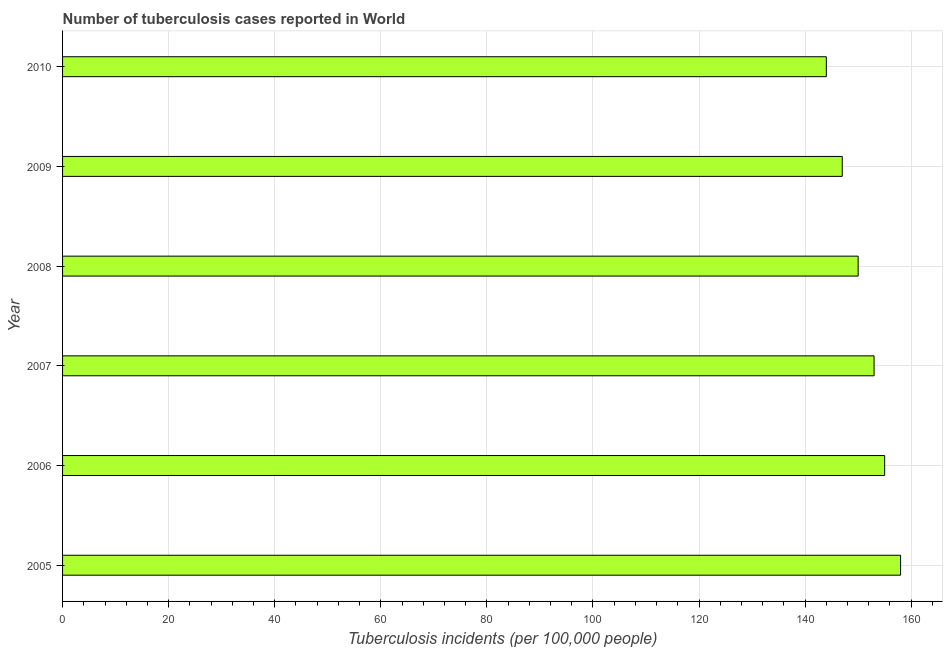Does the graph contain any zero values?
Keep it short and to the point. No. Does the graph contain grids?
Give a very brief answer. Yes. What is the title of the graph?
Ensure brevity in your answer.  Number of tuberculosis cases reported in World. What is the label or title of the X-axis?
Provide a succinct answer. Tuberculosis incidents (per 100,0 people). What is the label or title of the Y-axis?
Provide a short and direct response. Year. What is the number of tuberculosis incidents in 2008?
Make the answer very short. 150. Across all years, what is the maximum number of tuberculosis incidents?
Your answer should be very brief. 158. Across all years, what is the minimum number of tuberculosis incidents?
Provide a short and direct response. 144. In which year was the number of tuberculosis incidents minimum?
Your response must be concise. 2010. What is the sum of the number of tuberculosis incidents?
Ensure brevity in your answer.  907. What is the average number of tuberculosis incidents per year?
Ensure brevity in your answer.  151. What is the median number of tuberculosis incidents?
Give a very brief answer. 151.5. In how many years, is the number of tuberculosis incidents greater than 36 ?
Your answer should be compact. 6. Do a majority of the years between 2010 and 2005 (inclusive) have number of tuberculosis incidents greater than 24 ?
Your answer should be compact. Yes. What is the ratio of the number of tuberculosis incidents in 2007 to that in 2010?
Keep it short and to the point. 1.06. Is the difference between the number of tuberculosis incidents in 2006 and 2008 greater than the difference between any two years?
Ensure brevity in your answer.  No. Is the sum of the number of tuberculosis incidents in 2006 and 2008 greater than the maximum number of tuberculosis incidents across all years?
Give a very brief answer. Yes. Are all the bars in the graph horizontal?
Your answer should be very brief. Yes. How many years are there in the graph?
Offer a terse response. 6. Are the values on the major ticks of X-axis written in scientific E-notation?
Offer a very short reply. No. What is the Tuberculosis incidents (per 100,000 people) of 2005?
Give a very brief answer. 158. What is the Tuberculosis incidents (per 100,000 people) of 2006?
Ensure brevity in your answer.  155. What is the Tuberculosis incidents (per 100,000 people) in 2007?
Provide a succinct answer. 153. What is the Tuberculosis incidents (per 100,000 people) in 2008?
Give a very brief answer. 150. What is the Tuberculosis incidents (per 100,000 people) in 2009?
Your response must be concise. 147. What is the Tuberculosis incidents (per 100,000 people) in 2010?
Ensure brevity in your answer.  144. What is the difference between the Tuberculosis incidents (per 100,000 people) in 2005 and 2006?
Offer a terse response. 3. What is the difference between the Tuberculosis incidents (per 100,000 people) in 2005 and 2009?
Your response must be concise. 11. What is the difference between the Tuberculosis incidents (per 100,000 people) in 2005 and 2010?
Offer a very short reply. 14. What is the difference between the Tuberculosis incidents (per 100,000 people) in 2006 and 2008?
Offer a terse response. 5. What is the difference between the Tuberculosis incidents (per 100,000 people) in 2006 and 2010?
Your answer should be compact. 11. What is the difference between the Tuberculosis incidents (per 100,000 people) in 2007 and 2008?
Give a very brief answer. 3. What is the difference between the Tuberculosis incidents (per 100,000 people) in 2007 and 2009?
Keep it short and to the point. 6. What is the difference between the Tuberculosis incidents (per 100,000 people) in 2007 and 2010?
Offer a terse response. 9. What is the difference between the Tuberculosis incidents (per 100,000 people) in 2008 and 2009?
Your answer should be very brief. 3. What is the ratio of the Tuberculosis incidents (per 100,000 people) in 2005 to that in 2006?
Provide a short and direct response. 1.02. What is the ratio of the Tuberculosis incidents (per 100,000 people) in 2005 to that in 2007?
Keep it short and to the point. 1.03. What is the ratio of the Tuberculosis incidents (per 100,000 people) in 2005 to that in 2008?
Offer a terse response. 1.05. What is the ratio of the Tuberculosis incidents (per 100,000 people) in 2005 to that in 2009?
Provide a succinct answer. 1.07. What is the ratio of the Tuberculosis incidents (per 100,000 people) in 2005 to that in 2010?
Keep it short and to the point. 1.1. What is the ratio of the Tuberculosis incidents (per 100,000 people) in 2006 to that in 2008?
Ensure brevity in your answer.  1.03. What is the ratio of the Tuberculosis incidents (per 100,000 people) in 2006 to that in 2009?
Provide a short and direct response. 1.05. What is the ratio of the Tuberculosis incidents (per 100,000 people) in 2006 to that in 2010?
Your response must be concise. 1.08. What is the ratio of the Tuberculosis incidents (per 100,000 people) in 2007 to that in 2008?
Offer a terse response. 1.02. What is the ratio of the Tuberculosis incidents (per 100,000 people) in 2007 to that in 2009?
Provide a short and direct response. 1.04. What is the ratio of the Tuberculosis incidents (per 100,000 people) in 2007 to that in 2010?
Give a very brief answer. 1.06. What is the ratio of the Tuberculosis incidents (per 100,000 people) in 2008 to that in 2010?
Make the answer very short. 1.04. 